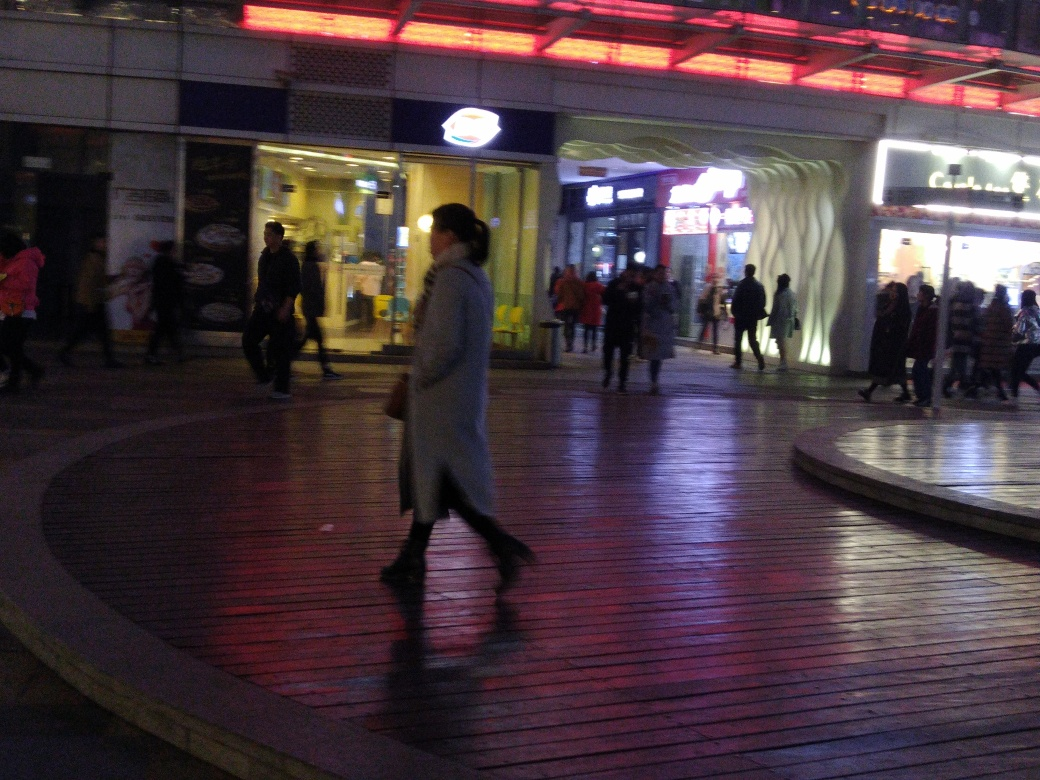How does the lighting affect the visual impact of the image? The lighting plays a crucial role in this image; it not only indicates the time of day but also accentuates the depth and texture of the scene. The interplay between the warm tones of the shop lights and the cooler shades of the evening sky generates contrast, making the photograph visually appealing. Furthermore, the strategic positioning of the lights creates a guiding path for the eye, leading it through the photograph and highlighting key elements such as the walking figures and the curving lines of the pavement. 